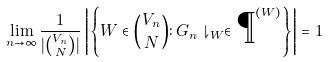Convert formula to latex. <formula><loc_0><loc_0><loc_500><loc_500>\lim _ { n \to \infty } \frac { 1 } { | \binom { V _ { n } } { N } | } \left | \left \{ W \in \binom { V _ { n } } { N } \colon G _ { n } \downharpoonright _ { W } \in \P ^ { ( W ) } \right \} \right | = 1</formula> 